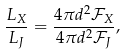<formula> <loc_0><loc_0><loc_500><loc_500>\frac { L _ { X } } { L _ { J } } = \frac { 4 \pi d ^ { 2 } { \mathcal { F } } _ { X } } { 4 \pi d ^ { 2 } { \mathcal { F } } _ { J } } ,</formula> 